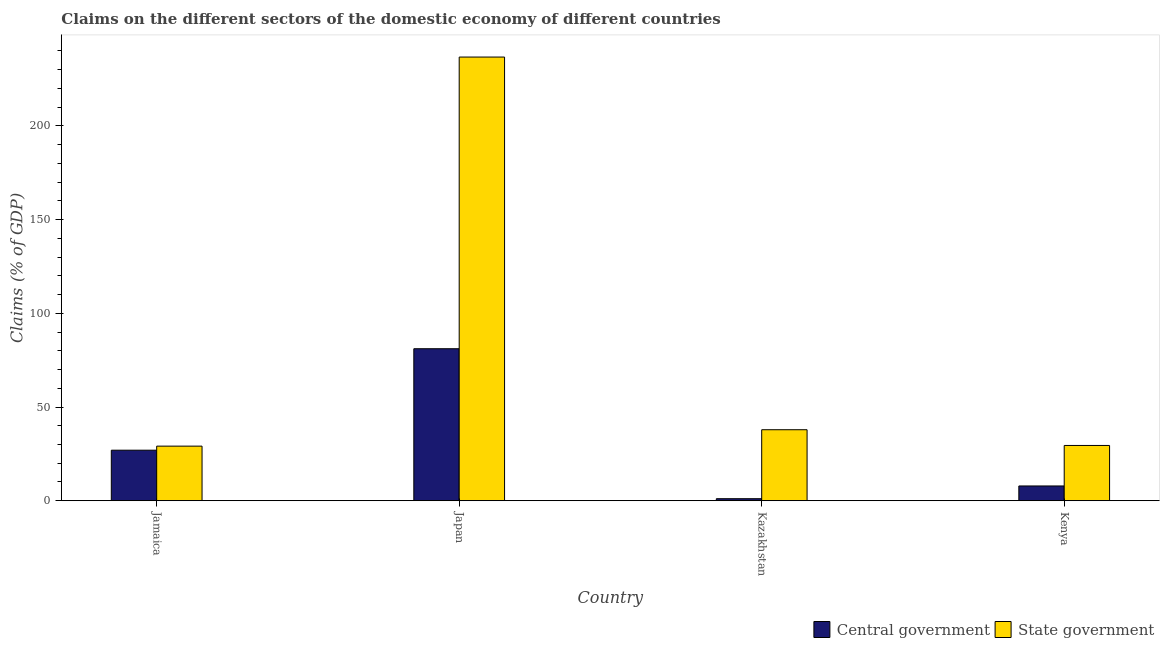Are the number of bars per tick equal to the number of legend labels?
Ensure brevity in your answer.  Yes. What is the label of the 3rd group of bars from the left?
Ensure brevity in your answer.  Kazakhstan. What is the claims on state government in Kazakhstan?
Offer a very short reply. 37.89. Across all countries, what is the maximum claims on state government?
Your answer should be very brief. 236.77. Across all countries, what is the minimum claims on central government?
Make the answer very short. 1.08. In which country was the claims on state government minimum?
Make the answer very short. Jamaica. What is the total claims on state government in the graph?
Keep it short and to the point. 333.27. What is the difference between the claims on state government in Jamaica and that in Japan?
Provide a succinct answer. -207.63. What is the difference between the claims on central government in Kenya and the claims on state government in Japan?
Offer a very short reply. -228.89. What is the average claims on state government per country?
Your answer should be compact. 83.32. What is the difference between the claims on central government and claims on state government in Japan?
Offer a very short reply. -155.65. In how many countries, is the claims on state government greater than 40 %?
Your answer should be very brief. 1. What is the ratio of the claims on central government in Jamaica to that in Kazakhstan?
Your response must be concise. 24.91. Is the claims on central government in Jamaica less than that in Japan?
Your response must be concise. Yes. Is the difference between the claims on state government in Japan and Kenya greater than the difference between the claims on central government in Japan and Kenya?
Make the answer very short. Yes. What is the difference between the highest and the second highest claims on central government?
Keep it short and to the point. 54.15. What is the difference between the highest and the lowest claims on state government?
Keep it short and to the point. 207.63. In how many countries, is the claims on central government greater than the average claims on central government taken over all countries?
Your response must be concise. 1. Is the sum of the claims on state government in Jamaica and Japan greater than the maximum claims on central government across all countries?
Offer a terse response. Yes. What does the 2nd bar from the left in Jamaica represents?
Your answer should be very brief. State government. What does the 1st bar from the right in Kazakhstan represents?
Your answer should be very brief. State government. How many bars are there?
Your answer should be compact. 8. Are all the bars in the graph horizontal?
Provide a succinct answer. No. How many countries are there in the graph?
Your response must be concise. 4. What is the difference between two consecutive major ticks on the Y-axis?
Your response must be concise. 50. Are the values on the major ticks of Y-axis written in scientific E-notation?
Your answer should be very brief. No. Does the graph contain grids?
Your answer should be compact. No. How many legend labels are there?
Ensure brevity in your answer.  2. How are the legend labels stacked?
Your answer should be very brief. Horizontal. What is the title of the graph?
Your answer should be very brief. Claims on the different sectors of the domestic economy of different countries. Does "Fixed telephone" appear as one of the legend labels in the graph?
Ensure brevity in your answer.  No. What is the label or title of the X-axis?
Provide a short and direct response. Country. What is the label or title of the Y-axis?
Your response must be concise. Claims (% of GDP). What is the Claims (% of GDP) of Central government in Jamaica?
Offer a terse response. 26.96. What is the Claims (% of GDP) in State government in Jamaica?
Keep it short and to the point. 29.13. What is the Claims (% of GDP) of Central government in Japan?
Your response must be concise. 81.11. What is the Claims (% of GDP) of State government in Japan?
Keep it short and to the point. 236.77. What is the Claims (% of GDP) of Central government in Kazakhstan?
Offer a terse response. 1.08. What is the Claims (% of GDP) of State government in Kazakhstan?
Provide a succinct answer. 37.89. What is the Claims (% of GDP) in Central government in Kenya?
Your answer should be compact. 7.87. What is the Claims (% of GDP) of State government in Kenya?
Make the answer very short. 29.49. Across all countries, what is the maximum Claims (% of GDP) in Central government?
Your response must be concise. 81.11. Across all countries, what is the maximum Claims (% of GDP) of State government?
Provide a succinct answer. 236.77. Across all countries, what is the minimum Claims (% of GDP) in Central government?
Offer a terse response. 1.08. Across all countries, what is the minimum Claims (% of GDP) of State government?
Provide a short and direct response. 29.13. What is the total Claims (% of GDP) of Central government in the graph?
Give a very brief answer. 117.03. What is the total Claims (% of GDP) in State government in the graph?
Give a very brief answer. 333.27. What is the difference between the Claims (% of GDP) of Central government in Jamaica and that in Japan?
Ensure brevity in your answer.  -54.15. What is the difference between the Claims (% of GDP) of State government in Jamaica and that in Japan?
Make the answer very short. -207.63. What is the difference between the Claims (% of GDP) of Central government in Jamaica and that in Kazakhstan?
Provide a succinct answer. 25.88. What is the difference between the Claims (% of GDP) of State government in Jamaica and that in Kazakhstan?
Offer a very short reply. -8.75. What is the difference between the Claims (% of GDP) of Central government in Jamaica and that in Kenya?
Offer a very short reply. 19.09. What is the difference between the Claims (% of GDP) in State government in Jamaica and that in Kenya?
Provide a succinct answer. -0.35. What is the difference between the Claims (% of GDP) of Central government in Japan and that in Kazakhstan?
Provide a succinct answer. 80.03. What is the difference between the Claims (% of GDP) in State government in Japan and that in Kazakhstan?
Your response must be concise. 198.88. What is the difference between the Claims (% of GDP) in Central government in Japan and that in Kenya?
Offer a terse response. 73.24. What is the difference between the Claims (% of GDP) of State government in Japan and that in Kenya?
Make the answer very short. 207.28. What is the difference between the Claims (% of GDP) of Central government in Kazakhstan and that in Kenya?
Provide a succinct answer. -6.79. What is the difference between the Claims (% of GDP) of State government in Kazakhstan and that in Kenya?
Ensure brevity in your answer.  8.4. What is the difference between the Claims (% of GDP) in Central government in Jamaica and the Claims (% of GDP) in State government in Japan?
Offer a terse response. -209.8. What is the difference between the Claims (% of GDP) of Central government in Jamaica and the Claims (% of GDP) of State government in Kazakhstan?
Provide a short and direct response. -10.92. What is the difference between the Claims (% of GDP) in Central government in Jamaica and the Claims (% of GDP) in State government in Kenya?
Provide a succinct answer. -2.52. What is the difference between the Claims (% of GDP) of Central government in Japan and the Claims (% of GDP) of State government in Kazakhstan?
Offer a very short reply. 43.23. What is the difference between the Claims (% of GDP) of Central government in Japan and the Claims (% of GDP) of State government in Kenya?
Provide a short and direct response. 51.63. What is the difference between the Claims (% of GDP) of Central government in Kazakhstan and the Claims (% of GDP) of State government in Kenya?
Your answer should be compact. -28.4. What is the average Claims (% of GDP) of Central government per country?
Your response must be concise. 29.26. What is the average Claims (% of GDP) of State government per country?
Ensure brevity in your answer.  83.32. What is the difference between the Claims (% of GDP) of Central government and Claims (% of GDP) of State government in Jamaica?
Provide a short and direct response. -2.17. What is the difference between the Claims (% of GDP) in Central government and Claims (% of GDP) in State government in Japan?
Offer a very short reply. -155.65. What is the difference between the Claims (% of GDP) of Central government and Claims (% of GDP) of State government in Kazakhstan?
Ensure brevity in your answer.  -36.8. What is the difference between the Claims (% of GDP) in Central government and Claims (% of GDP) in State government in Kenya?
Offer a very short reply. -21.61. What is the ratio of the Claims (% of GDP) in Central government in Jamaica to that in Japan?
Offer a very short reply. 0.33. What is the ratio of the Claims (% of GDP) in State government in Jamaica to that in Japan?
Your response must be concise. 0.12. What is the ratio of the Claims (% of GDP) in Central government in Jamaica to that in Kazakhstan?
Your answer should be compact. 24.91. What is the ratio of the Claims (% of GDP) in State government in Jamaica to that in Kazakhstan?
Make the answer very short. 0.77. What is the ratio of the Claims (% of GDP) in Central government in Jamaica to that in Kenya?
Give a very brief answer. 3.42. What is the ratio of the Claims (% of GDP) of State government in Jamaica to that in Kenya?
Your answer should be compact. 0.99. What is the ratio of the Claims (% of GDP) in Central government in Japan to that in Kazakhstan?
Ensure brevity in your answer.  74.93. What is the ratio of the Claims (% of GDP) of State government in Japan to that in Kazakhstan?
Your answer should be very brief. 6.25. What is the ratio of the Claims (% of GDP) in Central government in Japan to that in Kenya?
Offer a very short reply. 10.3. What is the ratio of the Claims (% of GDP) of State government in Japan to that in Kenya?
Give a very brief answer. 8.03. What is the ratio of the Claims (% of GDP) in Central government in Kazakhstan to that in Kenya?
Make the answer very short. 0.14. What is the ratio of the Claims (% of GDP) of State government in Kazakhstan to that in Kenya?
Your answer should be very brief. 1.28. What is the difference between the highest and the second highest Claims (% of GDP) of Central government?
Provide a short and direct response. 54.15. What is the difference between the highest and the second highest Claims (% of GDP) in State government?
Give a very brief answer. 198.88. What is the difference between the highest and the lowest Claims (% of GDP) of Central government?
Offer a terse response. 80.03. What is the difference between the highest and the lowest Claims (% of GDP) in State government?
Your response must be concise. 207.63. 